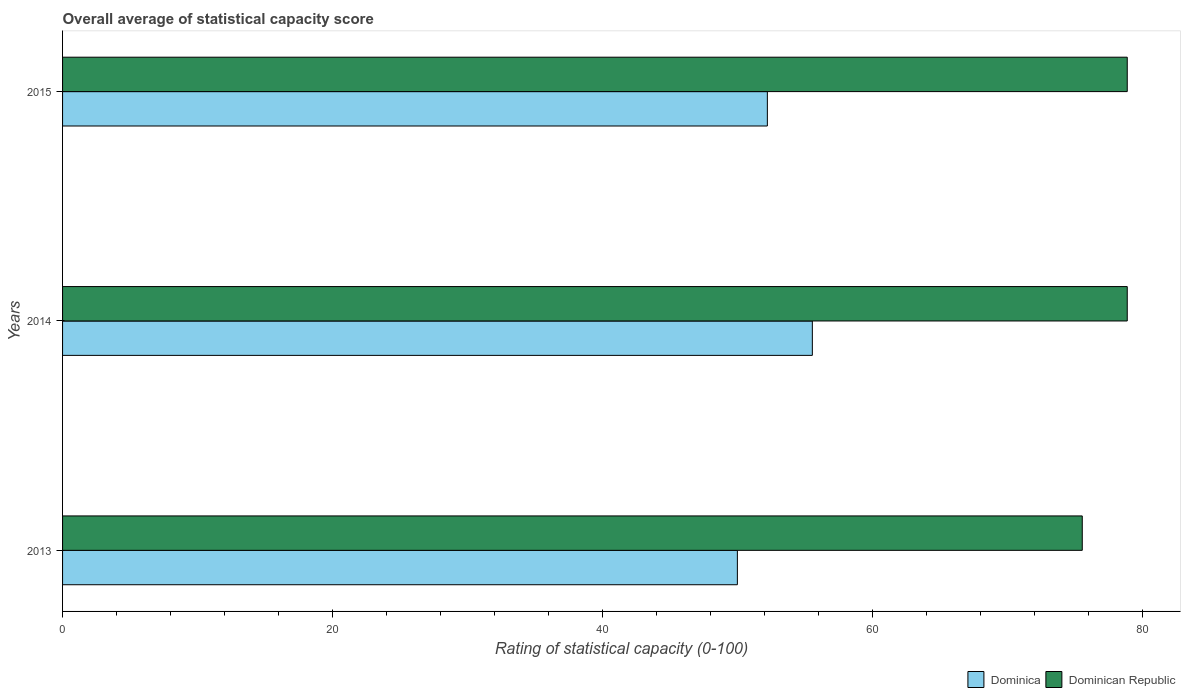Are the number of bars on each tick of the Y-axis equal?
Your response must be concise. Yes. How many bars are there on the 3rd tick from the top?
Your answer should be very brief. 2. How many bars are there on the 3rd tick from the bottom?
Your answer should be compact. 2. What is the rating of statistical capacity in Dominican Republic in 2013?
Provide a short and direct response. 75.56. Across all years, what is the maximum rating of statistical capacity in Dominica?
Provide a short and direct response. 55.56. In which year was the rating of statistical capacity in Dominican Republic maximum?
Offer a terse response. 2015. What is the total rating of statistical capacity in Dominican Republic in the graph?
Provide a short and direct response. 233.33. What is the difference between the rating of statistical capacity in Dominican Republic in 2013 and that in 2014?
Your answer should be compact. -3.33. What is the difference between the rating of statistical capacity in Dominican Republic in 2013 and the rating of statistical capacity in Dominica in 2015?
Your response must be concise. 23.33. What is the average rating of statistical capacity in Dominican Republic per year?
Give a very brief answer. 77.78. In the year 2015, what is the difference between the rating of statistical capacity in Dominican Republic and rating of statistical capacity in Dominica?
Offer a very short reply. 26.67. In how many years, is the rating of statistical capacity in Dominican Republic greater than 32 ?
Provide a short and direct response. 3. What is the ratio of the rating of statistical capacity in Dominican Republic in 2014 to that in 2015?
Keep it short and to the point. 1. Is the rating of statistical capacity in Dominica in 2014 less than that in 2015?
Your answer should be very brief. No. What is the difference between the highest and the second highest rating of statistical capacity in Dominican Republic?
Offer a terse response. 1.111111110674301e-5. What is the difference between the highest and the lowest rating of statistical capacity in Dominica?
Offer a very short reply. 5.56. Is the sum of the rating of statistical capacity in Dominican Republic in 2014 and 2015 greater than the maximum rating of statistical capacity in Dominica across all years?
Give a very brief answer. Yes. What does the 2nd bar from the top in 2015 represents?
Your answer should be very brief. Dominica. What does the 2nd bar from the bottom in 2013 represents?
Offer a terse response. Dominican Republic. Are all the bars in the graph horizontal?
Ensure brevity in your answer.  Yes. How many years are there in the graph?
Provide a succinct answer. 3. What is the difference between two consecutive major ticks on the X-axis?
Offer a terse response. 20. How are the legend labels stacked?
Your response must be concise. Horizontal. What is the title of the graph?
Provide a succinct answer. Overall average of statistical capacity score. Does "Somalia" appear as one of the legend labels in the graph?
Give a very brief answer. No. What is the label or title of the X-axis?
Keep it short and to the point. Rating of statistical capacity (0-100). What is the label or title of the Y-axis?
Give a very brief answer. Years. What is the Rating of statistical capacity (0-100) of Dominica in 2013?
Provide a short and direct response. 50. What is the Rating of statistical capacity (0-100) in Dominican Republic in 2013?
Your answer should be very brief. 75.56. What is the Rating of statistical capacity (0-100) in Dominica in 2014?
Your answer should be very brief. 55.56. What is the Rating of statistical capacity (0-100) in Dominican Republic in 2014?
Provide a short and direct response. 78.89. What is the Rating of statistical capacity (0-100) of Dominica in 2015?
Provide a short and direct response. 52.22. What is the Rating of statistical capacity (0-100) in Dominican Republic in 2015?
Give a very brief answer. 78.89. Across all years, what is the maximum Rating of statistical capacity (0-100) in Dominica?
Give a very brief answer. 55.56. Across all years, what is the maximum Rating of statistical capacity (0-100) of Dominican Republic?
Your answer should be very brief. 78.89. Across all years, what is the minimum Rating of statistical capacity (0-100) of Dominican Republic?
Provide a succinct answer. 75.56. What is the total Rating of statistical capacity (0-100) in Dominica in the graph?
Offer a very short reply. 157.78. What is the total Rating of statistical capacity (0-100) in Dominican Republic in the graph?
Provide a short and direct response. 233.33. What is the difference between the Rating of statistical capacity (0-100) in Dominica in 2013 and that in 2014?
Offer a terse response. -5.56. What is the difference between the Rating of statistical capacity (0-100) of Dominican Republic in 2013 and that in 2014?
Offer a very short reply. -3.33. What is the difference between the Rating of statistical capacity (0-100) in Dominica in 2013 and that in 2015?
Ensure brevity in your answer.  -2.22. What is the difference between the Rating of statistical capacity (0-100) in Dominica in 2013 and the Rating of statistical capacity (0-100) in Dominican Republic in 2014?
Your answer should be compact. -28.89. What is the difference between the Rating of statistical capacity (0-100) in Dominica in 2013 and the Rating of statistical capacity (0-100) in Dominican Republic in 2015?
Make the answer very short. -28.89. What is the difference between the Rating of statistical capacity (0-100) of Dominica in 2014 and the Rating of statistical capacity (0-100) of Dominican Republic in 2015?
Your answer should be very brief. -23.33. What is the average Rating of statistical capacity (0-100) of Dominica per year?
Offer a very short reply. 52.59. What is the average Rating of statistical capacity (0-100) in Dominican Republic per year?
Make the answer very short. 77.78. In the year 2013, what is the difference between the Rating of statistical capacity (0-100) in Dominica and Rating of statistical capacity (0-100) in Dominican Republic?
Make the answer very short. -25.56. In the year 2014, what is the difference between the Rating of statistical capacity (0-100) of Dominica and Rating of statistical capacity (0-100) of Dominican Republic?
Keep it short and to the point. -23.33. In the year 2015, what is the difference between the Rating of statistical capacity (0-100) in Dominica and Rating of statistical capacity (0-100) in Dominican Republic?
Provide a succinct answer. -26.67. What is the ratio of the Rating of statistical capacity (0-100) in Dominican Republic in 2013 to that in 2014?
Your answer should be compact. 0.96. What is the ratio of the Rating of statistical capacity (0-100) in Dominica in 2013 to that in 2015?
Provide a succinct answer. 0.96. What is the ratio of the Rating of statistical capacity (0-100) of Dominican Republic in 2013 to that in 2015?
Make the answer very short. 0.96. What is the ratio of the Rating of statistical capacity (0-100) of Dominica in 2014 to that in 2015?
Offer a terse response. 1.06. What is the difference between the highest and the second highest Rating of statistical capacity (0-100) of Dominican Republic?
Offer a very short reply. 0. What is the difference between the highest and the lowest Rating of statistical capacity (0-100) of Dominica?
Your response must be concise. 5.56. 